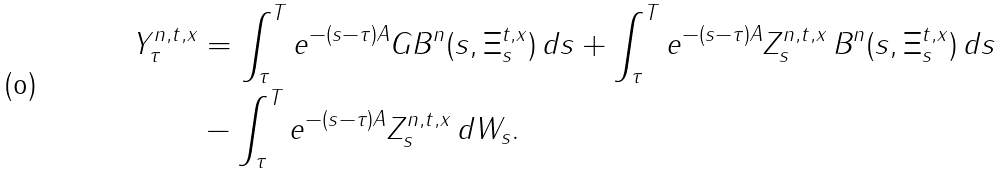<formula> <loc_0><loc_0><loc_500><loc_500>Y _ { \tau } ^ { n , t , x } & = \int _ { \tau } ^ { T } e ^ { - ( s - \tau ) { A } } G B ^ { n } ( s , \Xi ^ { t , x } _ { s } ) \, d s + \int _ { \tau } ^ { T } e ^ { - ( s - \tau ) { A } } Z _ { s } ^ { n , t , x } \, B ^ { n } ( s , \Xi ^ { t , x } _ { s } ) \, d s \\ & - \int _ { \tau } ^ { T } e ^ { - ( s - \tau ) { A } } Z ^ { n , t , x } _ { s } \, d W _ { s } .</formula> 